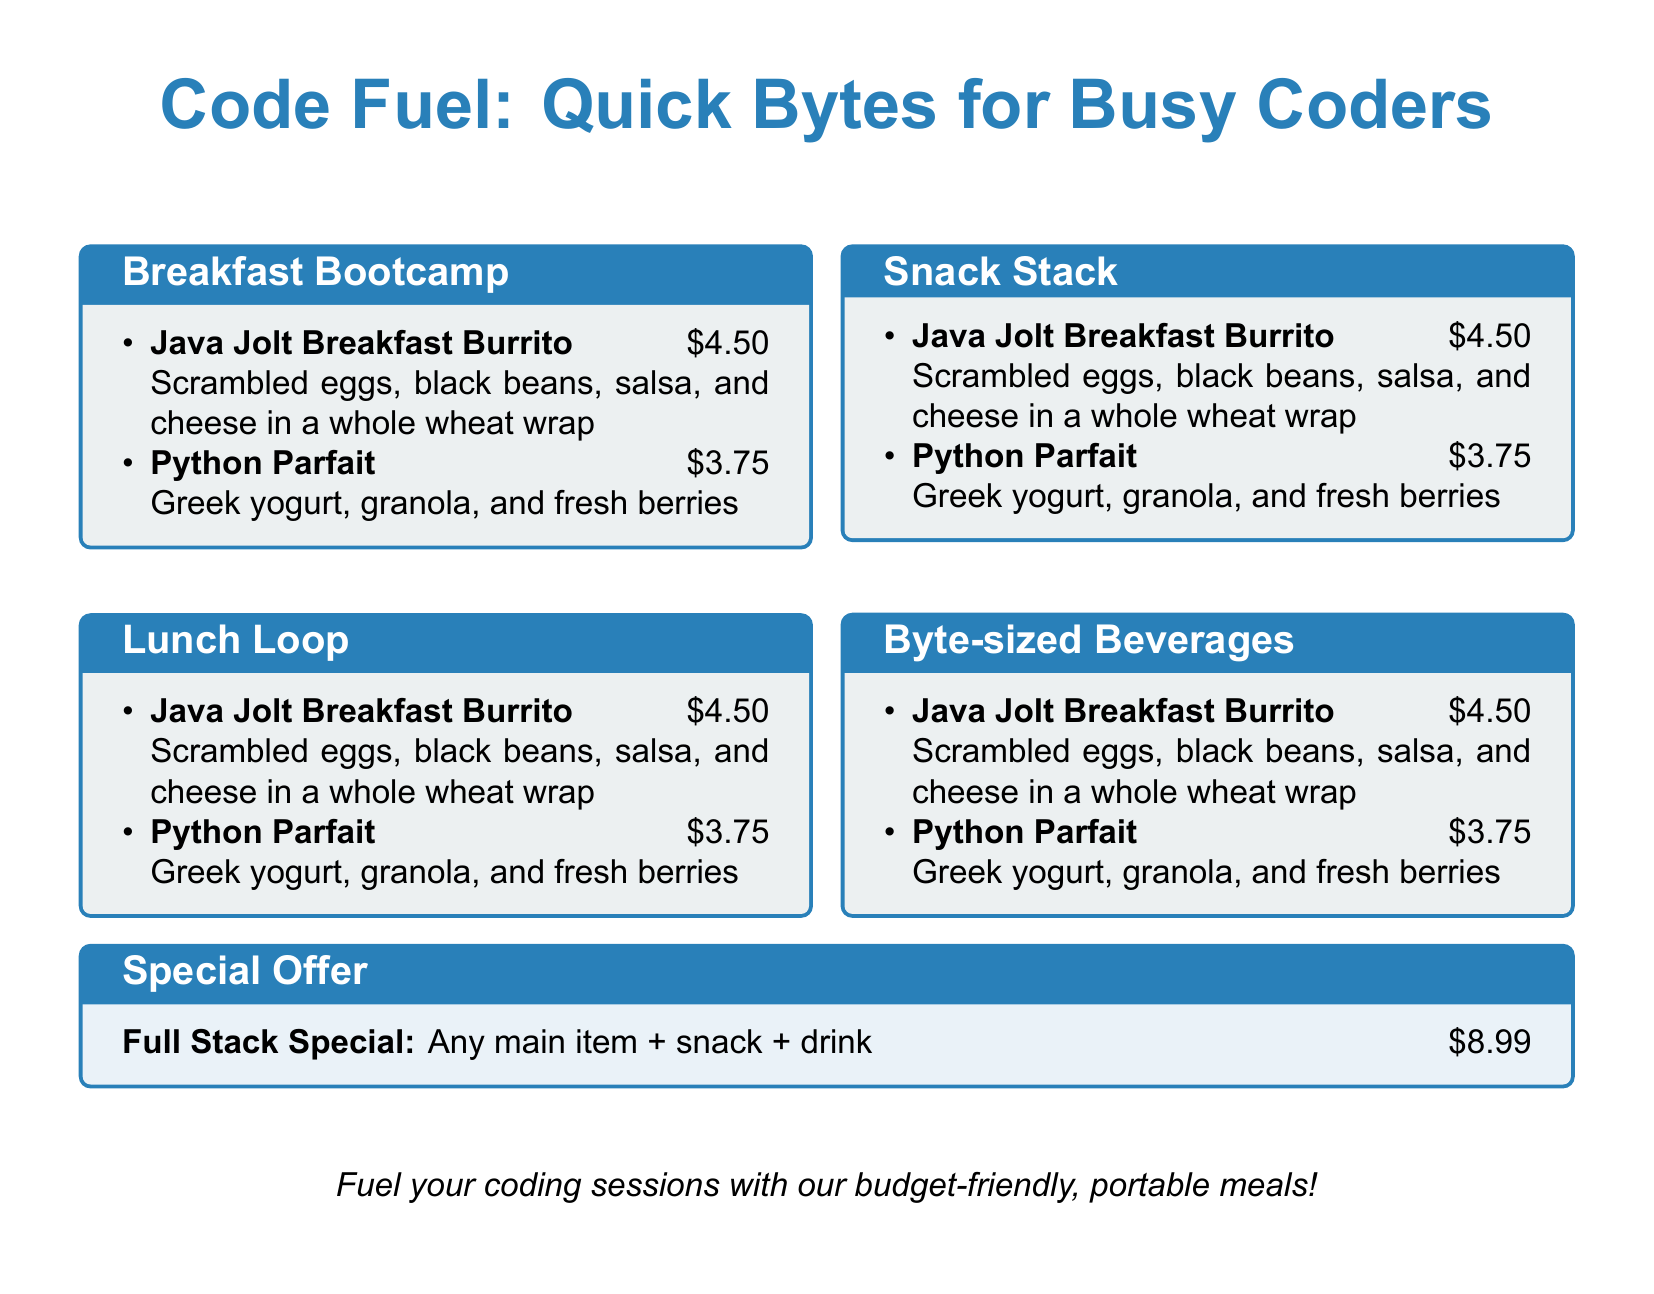What is the name of the breakfast item? The menu lists a breakfast item called "Java Jolt Breakfast Burrito."
Answer: Java Jolt Breakfast Burrito How much does the Python Parfait cost? The price for the "Python Parfait" is stated as $3.75.
Answer: $3.75 What type of wrap is used in the breakfast burrito? The breakfast burrito uses a whole wheat wrap.
Answer: whole wheat wrap What is included in the Full Stack Special? The Full Stack Special includes any main item, a snack, and a drink.
Answer: Any main item + snack + drink What is the total cost for the Full Stack Special? The cost of the Full Stack Special is $8.99 as stated in the document.
Answer: $8.99 Which category lists snacks? The document includes a category named "Snack Stack."
Answer: Snack Stack How many main items are listed under the Breakfast Bootcamp category? There are two main items listed under "Breakfast Bootcamp."
Answer: 2 What ingredient is not mentioned in the system of the burrito? The burrito does not list any type of meat.
Answer: None What is the theme of the food truck menu? The menu theme is aimed at busy coders needing quick meals.
Answer: Quick Bytes for Busy Coders 